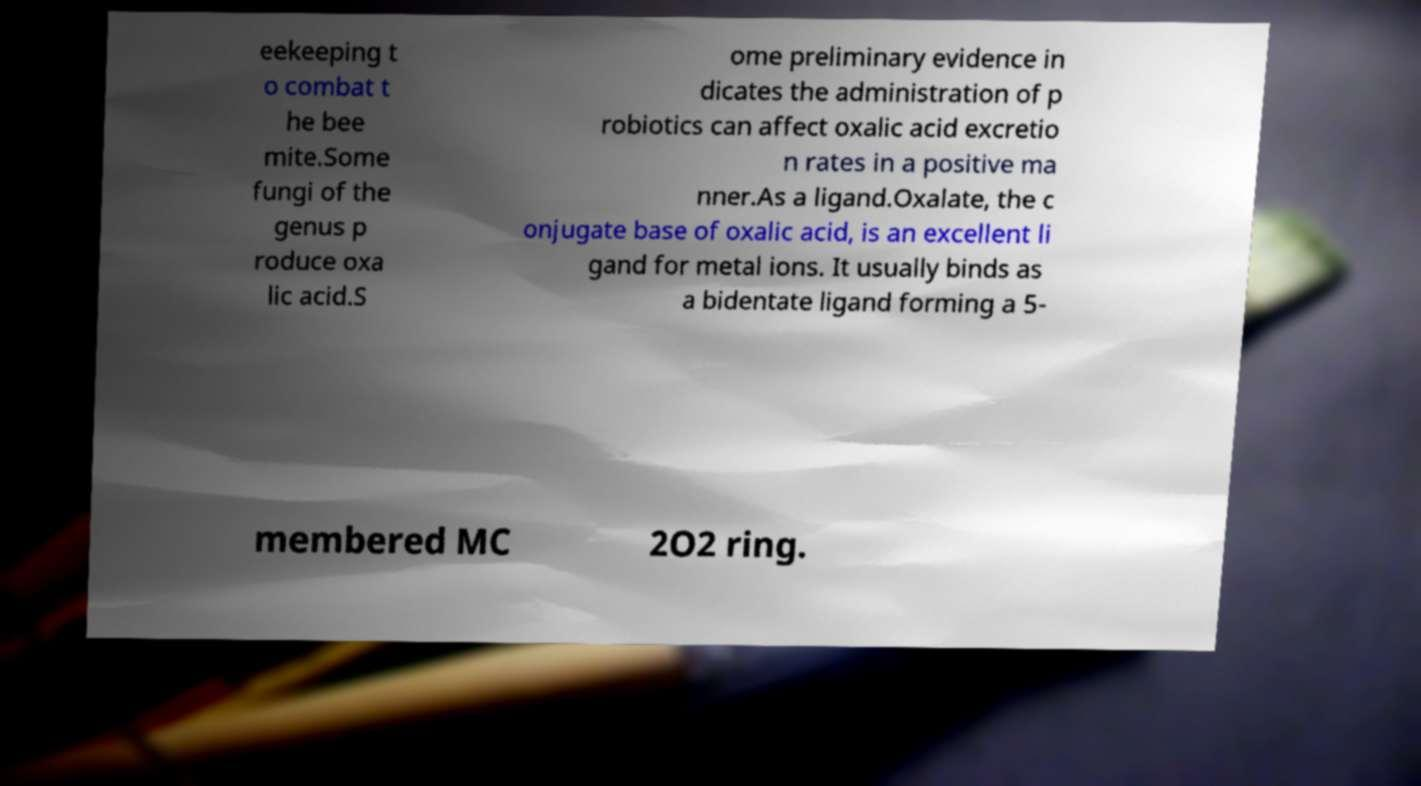Please read and relay the text visible in this image. What does it say? eekeeping t o combat t he bee mite.Some fungi of the genus p roduce oxa lic acid.S ome preliminary evidence in dicates the administration of p robiotics can affect oxalic acid excretio n rates in a positive ma nner.As a ligand.Oxalate, the c onjugate base of oxalic acid, is an excellent li gand for metal ions. It usually binds as a bidentate ligand forming a 5- membered MC 2O2 ring. 